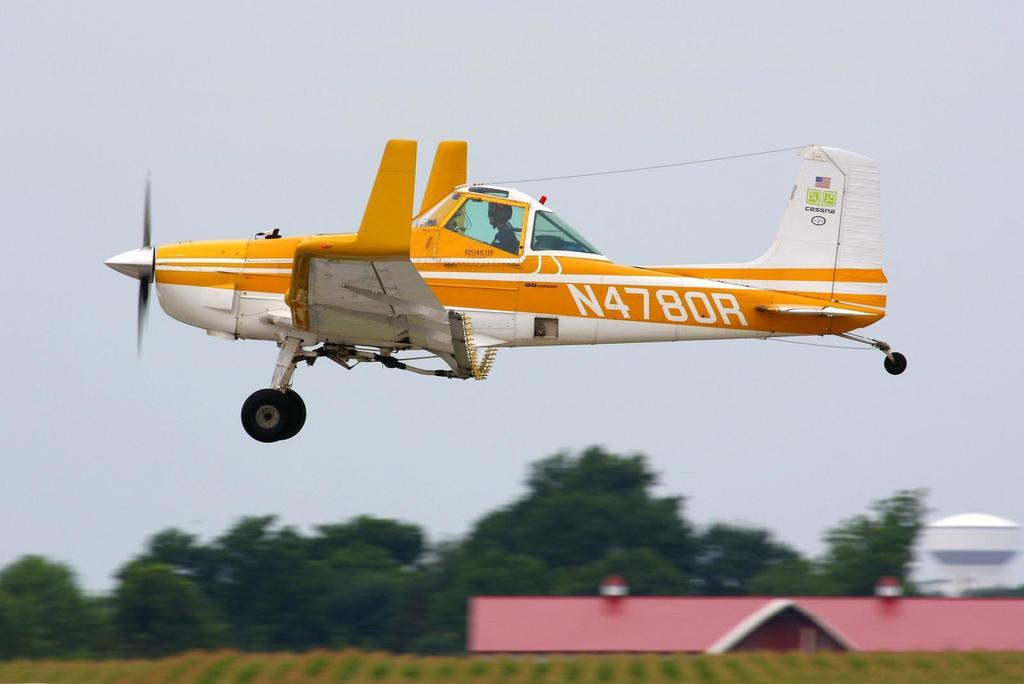<image>
Share a concise interpretation of the image provided. A yellow prop plane in flight has N4780R on its fuselage. 